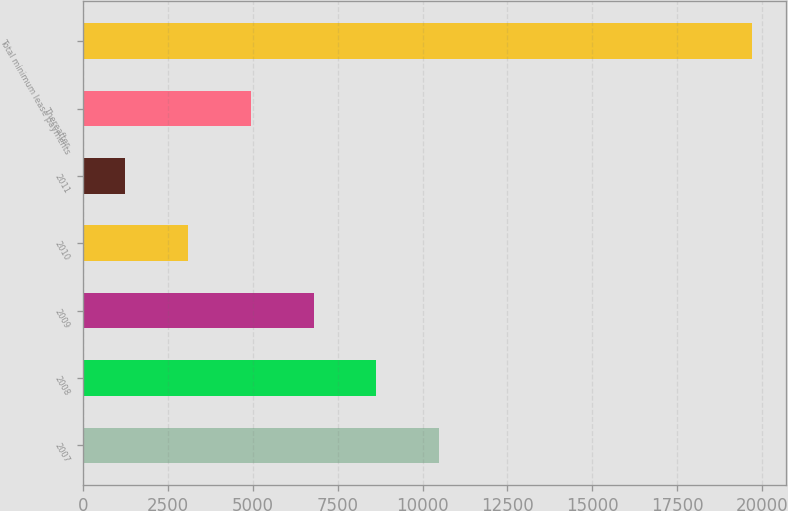Convert chart to OTSL. <chart><loc_0><loc_0><loc_500><loc_500><bar_chart><fcel>2007<fcel>2008<fcel>2009<fcel>2010<fcel>2011<fcel>Thereafter<fcel>Total minimum lease payments<nl><fcel>10482<fcel>8635.6<fcel>6789.2<fcel>3096.4<fcel>1250<fcel>4942.8<fcel>19714<nl></chart> 